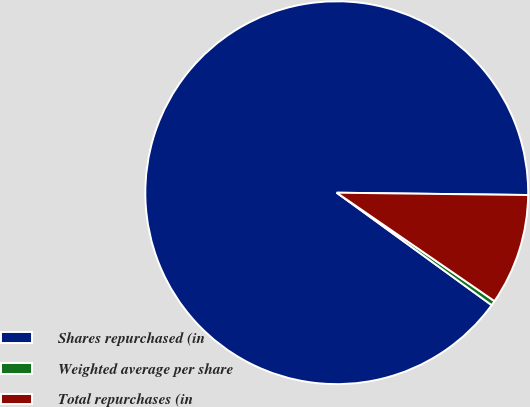<chart> <loc_0><loc_0><loc_500><loc_500><pie_chart><fcel>Shares repurchased (in<fcel>Weighted average per share<fcel>Total repurchases (in<nl><fcel>90.19%<fcel>0.41%<fcel>9.39%<nl></chart> 